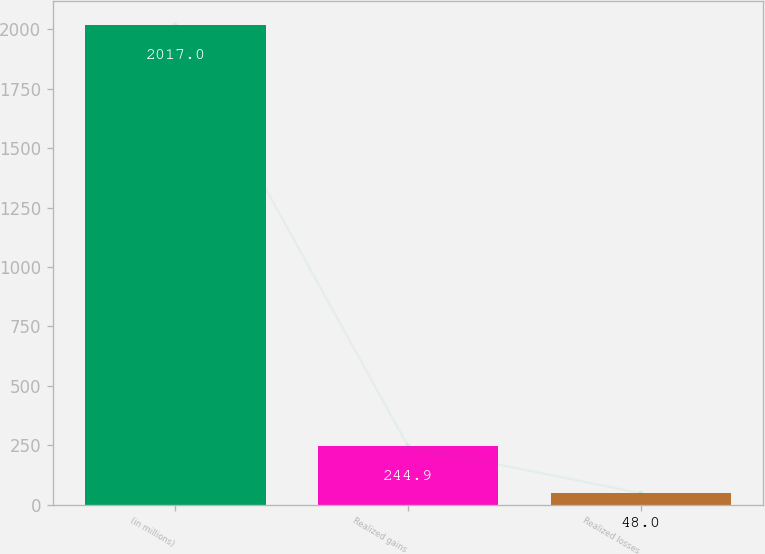<chart> <loc_0><loc_0><loc_500><loc_500><bar_chart><fcel>(in millions)<fcel>Realized gains<fcel>Realized losses<nl><fcel>2017<fcel>244.9<fcel>48<nl></chart> 